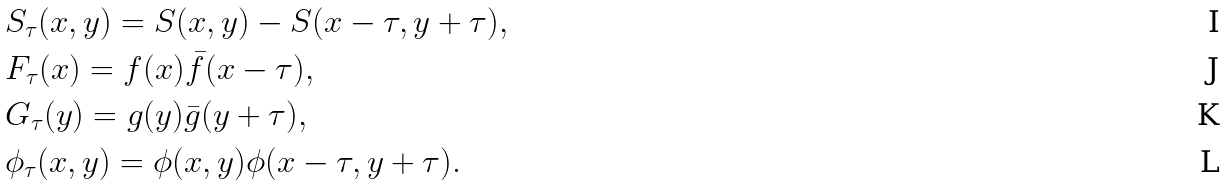<formula> <loc_0><loc_0><loc_500><loc_500>& S _ { \tau } ( x , y ) = S ( x , y ) - S ( x - \tau , y + \tau ) , \\ & F _ { \tau } ( x ) = f ( x ) \bar { f } ( x - \tau ) , \\ & G _ { \tau } ( y ) = g ( y ) \bar { g } ( y + \tau ) , \\ & \phi _ { \tau } ( x , y ) = \phi ( x , y ) \phi ( x - \tau , y + \tau ) .</formula> 